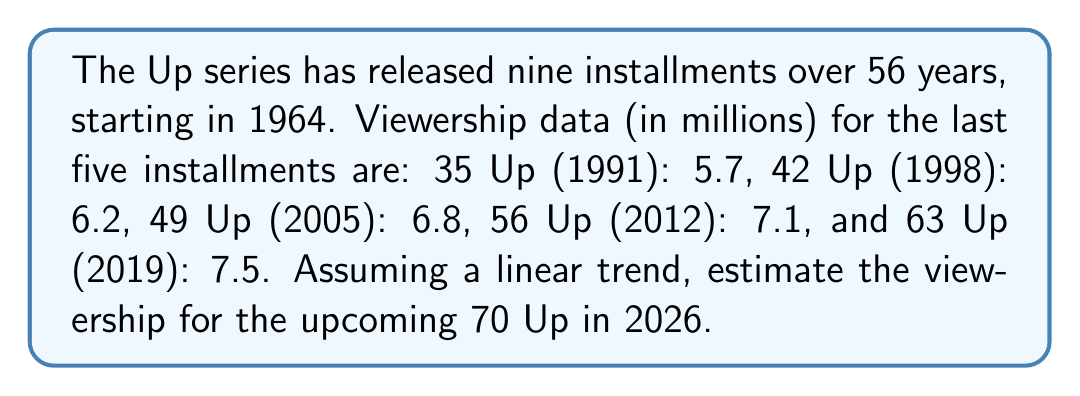Can you solve this math problem? To estimate the viewership for 70 Up, we'll use linear regression:

1. Let x be the years since 1964, and y be the viewership in millions.
2. Data points: (27, 5.7), (34, 6.2), (41, 6.8), (48, 7.1), (55, 7.5)
3. Calculate means: $\bar{x} = 41$, $\bar{y} = 6.66$
4. Calculate slope (m):
   $$m = \frac{\sum(x_i - \bar{x})(y_i - \bar{y})}{\sum(x_i - \bar{x})^2}$$
   $$m = \frac{70.84}{784} \approx 0.0903$$
5. Calculate y-intercept (b):
   $$b = \bar{y} - m\bar{x} \approx 2.9577$$
6. Linear equation: $y = 0.0903x + 2.9577$
7. For 70 Up (2026), x = 62 (years since 1964)
8. Estimated viewership:
   $$y = 0.0903(62) + 2.9577 \approx 8.5563$$
Answer: 8.56 million viewers 